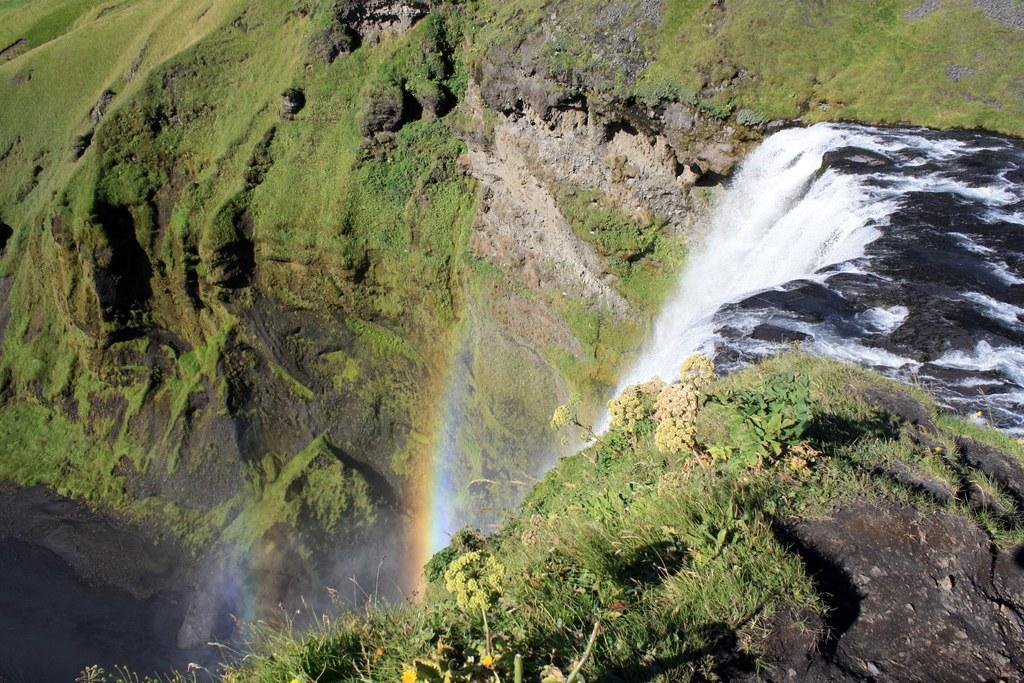What type of vegetation can be seen in the image? There are plants and grass in the image. What color are the plants and grass in the image? The plants and grass are green in the image. What natural feature is present in the image? There is a waterfall in the image. What additional atmospheric phenomenon can be seen in the image? There is a rainbow in the image. What type of milk is being poured into the plant in the image? There is no milk being poured into a plant in the image; the plants are green and not being watered or fed in any way. 